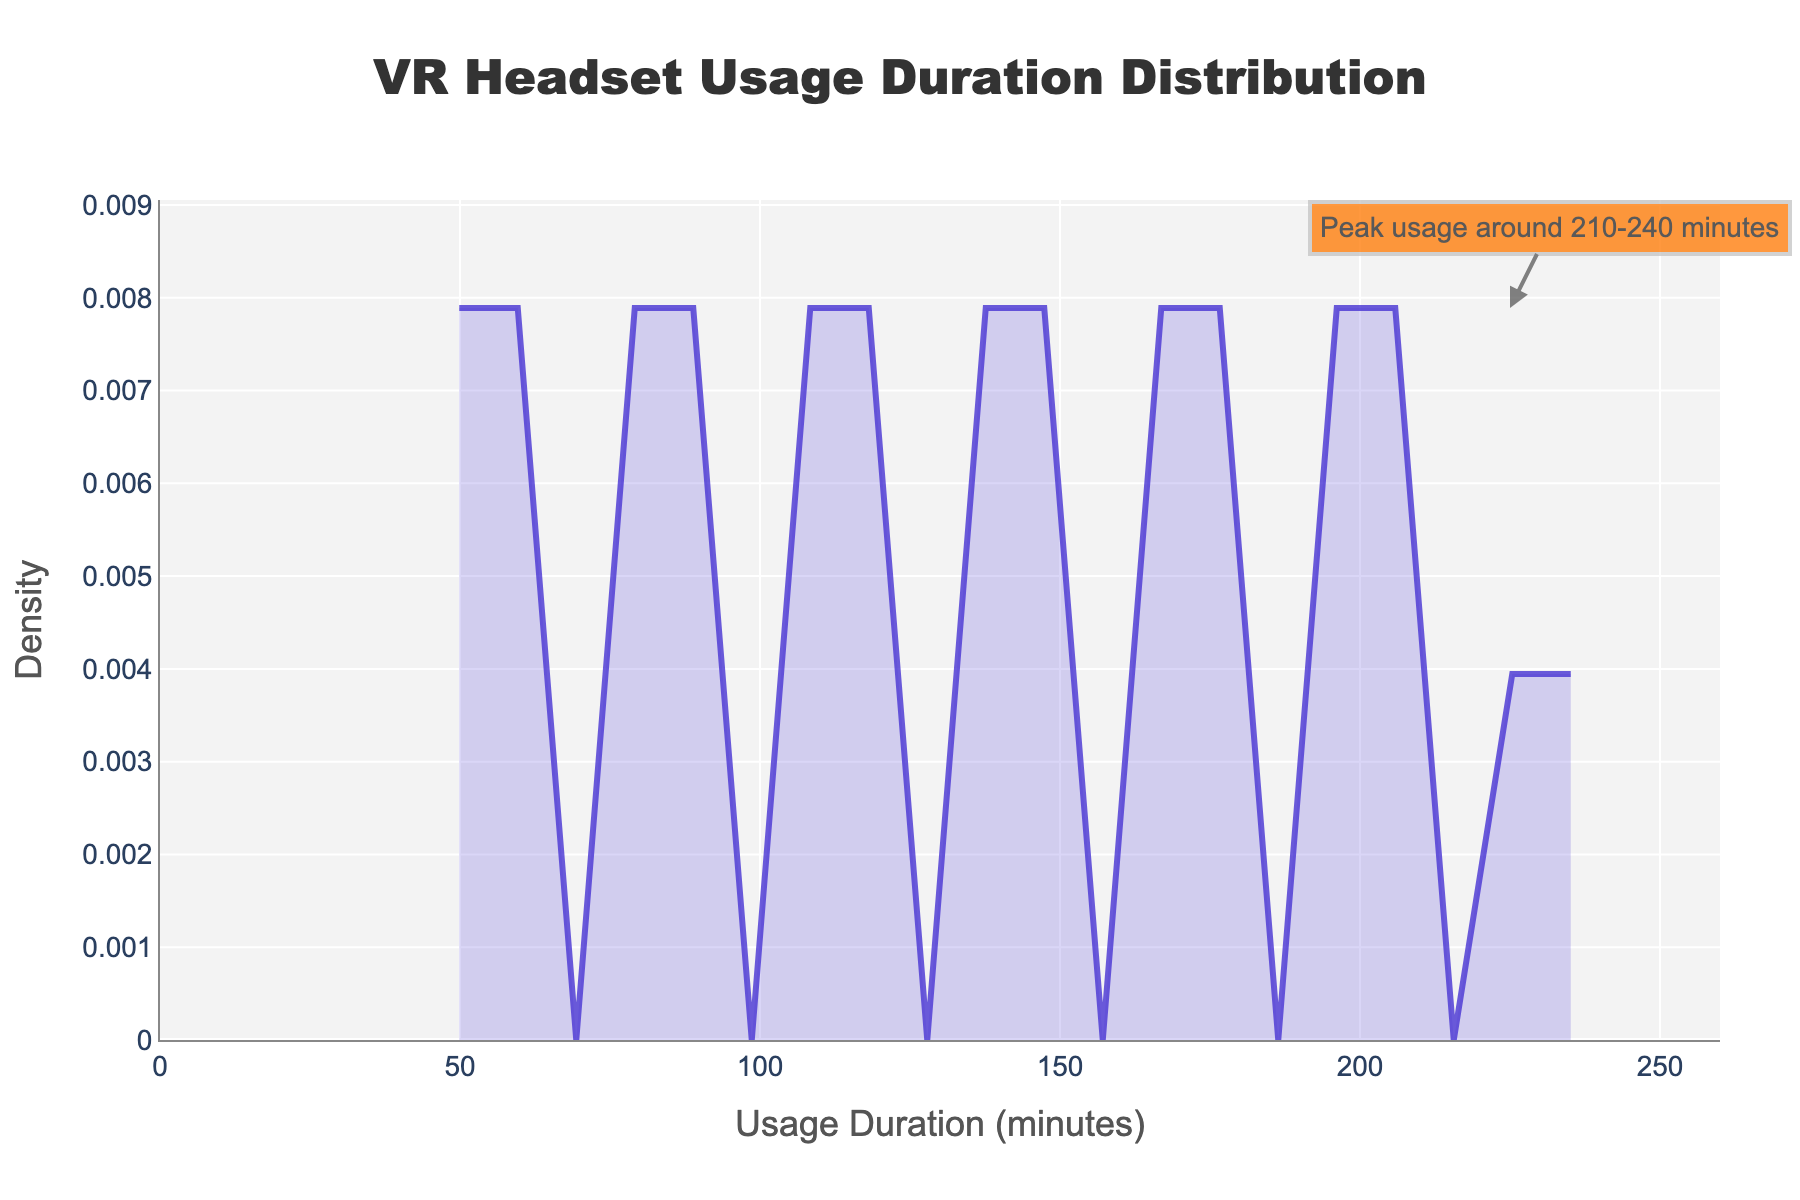What is the title of the plot? The title of the plot is usually situated at the top and gives an overview of what the plot is about. Here, you can see the title "VR Headset Usage Duration Distribution" positioned centrally at the top.
Answer: VR Headset Usage Duration Distribution What do the x-axis and y-axis represent? The x-axis usually shows the variable being measured, while the y-axis shows the density of occurrences within those measurements. Here, the x-axis represents "Usage Duration (minutes)" and the y-axis represents "Density".
Answer: Usage Duration (minutes) and Density Around which usage duration does the highest density occur? By observing the density plot, you can see that the highest point on the y-axis is pointed out by an annotation near the x-axis values of approximately 210-240 minutes.
Answer: 210-240 minutes Which age groups correspond to the density peak of 210-240 minutes? From the given dataset, you can refer to the ages where usage durations around 210-240 minutes occur. Ages such as 38 and 40 have usage durations of 225 and 240 minutes, respectively.
Answer: 38 and 40 What is the general trend of VR headset usage duration with age? By looking at the density plot, the peak suggests that younger people tend to use VR headsets for a longer duration, and older people use them for a shorter duration. This is evident as the high density of longer usage times is occurring around the ages of 18 to 42.
Answer: Younger people use VR for a longer duration Are there any usage durations with zero density? A density of zero would mean the line touches the x-axis. From the plot, there are no points where the density line touches the x-axis, indicating that all usage durations have some density.
Answer: No What can be inferred from the shading under the density curve? The shading under the density curve highlights the area where usage durations commonly fall. Darker shades beneath higher peaks indicate more common durations, especially around 210-240 minutes, signifying more frequent usage times in that range.
Answer: Higher commonality around 210-240 minutes How does the density change as the usage duration increases from 45 to 240 minutes? Observing the density curve, it can be seen that the density generally increases reaching a peak at around 210-240 minutes and then declines. This signifies that fewer people use the VR headset for shorter or very long durations compared to those in the 210-240 minute range.
Answer: Initially increases, peaks at 210-240 minutes, then declines 